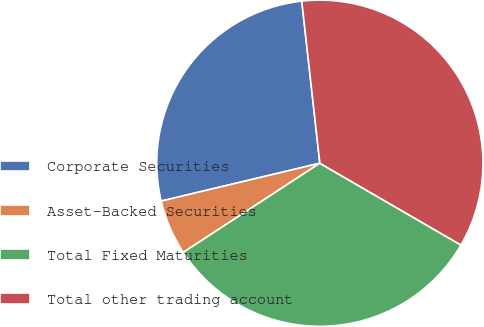Convert chart. <chart><loc_0><loc_0><loc_500><loc_500><pie_chart><fcel>Corporate Securities<fcel>Asset-Backed Securities<fcel>Total Fixed Maturities<fcel>Total other trading account<nl><fcel>26.96%<fcel>5.48%<fcel>32.43%<fcel>35.13%<nl></chart> 